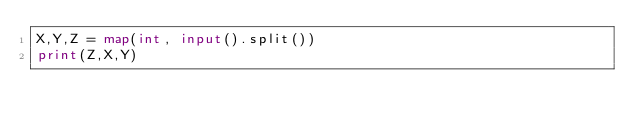<code> <loc_0><loc_0><loc_500><loc_500><_Python_>X,Y,Z = map(int, input().split())
print(Z,X,Y)</code> 